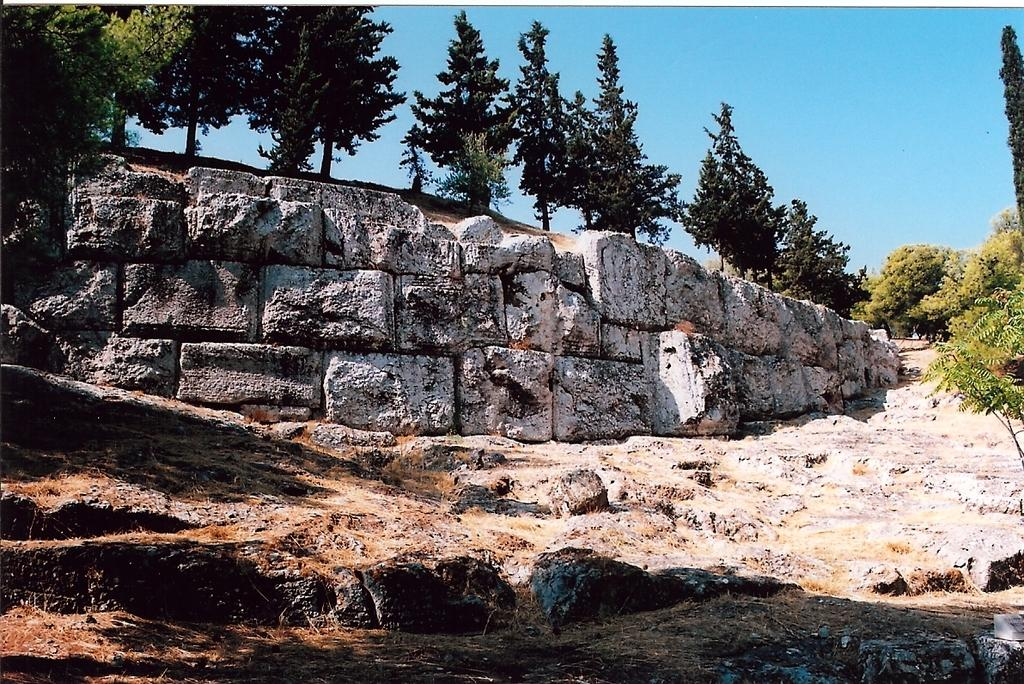What type of natural elements can be seen in the image? There are rocks and trees in the image. Can you describe the rocks in the image? The provided facts do not give specific details about the rocks, so we cannot describe them further. What type of vegetation is present in the image? There are trees in the image. What type of feather can be seen on the rocks in the image? There is no feather present on the rocks in the image. How does the image stop time for the rocks and trees? The image does not stop time for the rocks and trees; it is a still image capturing a moment in time. 